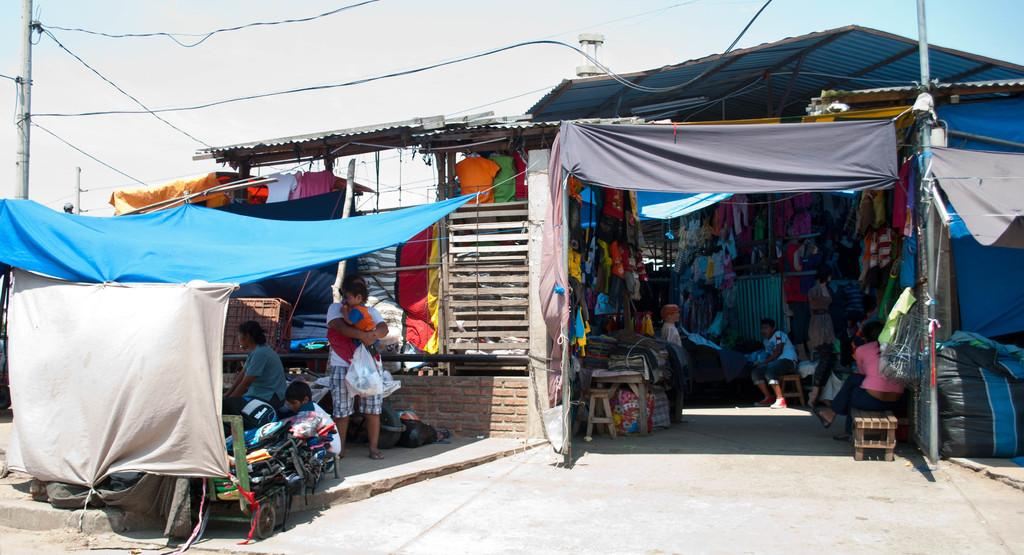What type of establishment is shown in the image? There is a store in the image. What are the people in the store doing? There are people sitting in the store. Can you describe the person who is standing? The person who is standing is carrying a baby and an object. What can be found in abundance in the store? There are many clothes in the store. What type of glue is being used to attach the flesh to the plastic in the image? There is no glue, flesh, or plastic present in the image; it features a store with people and clothes. 